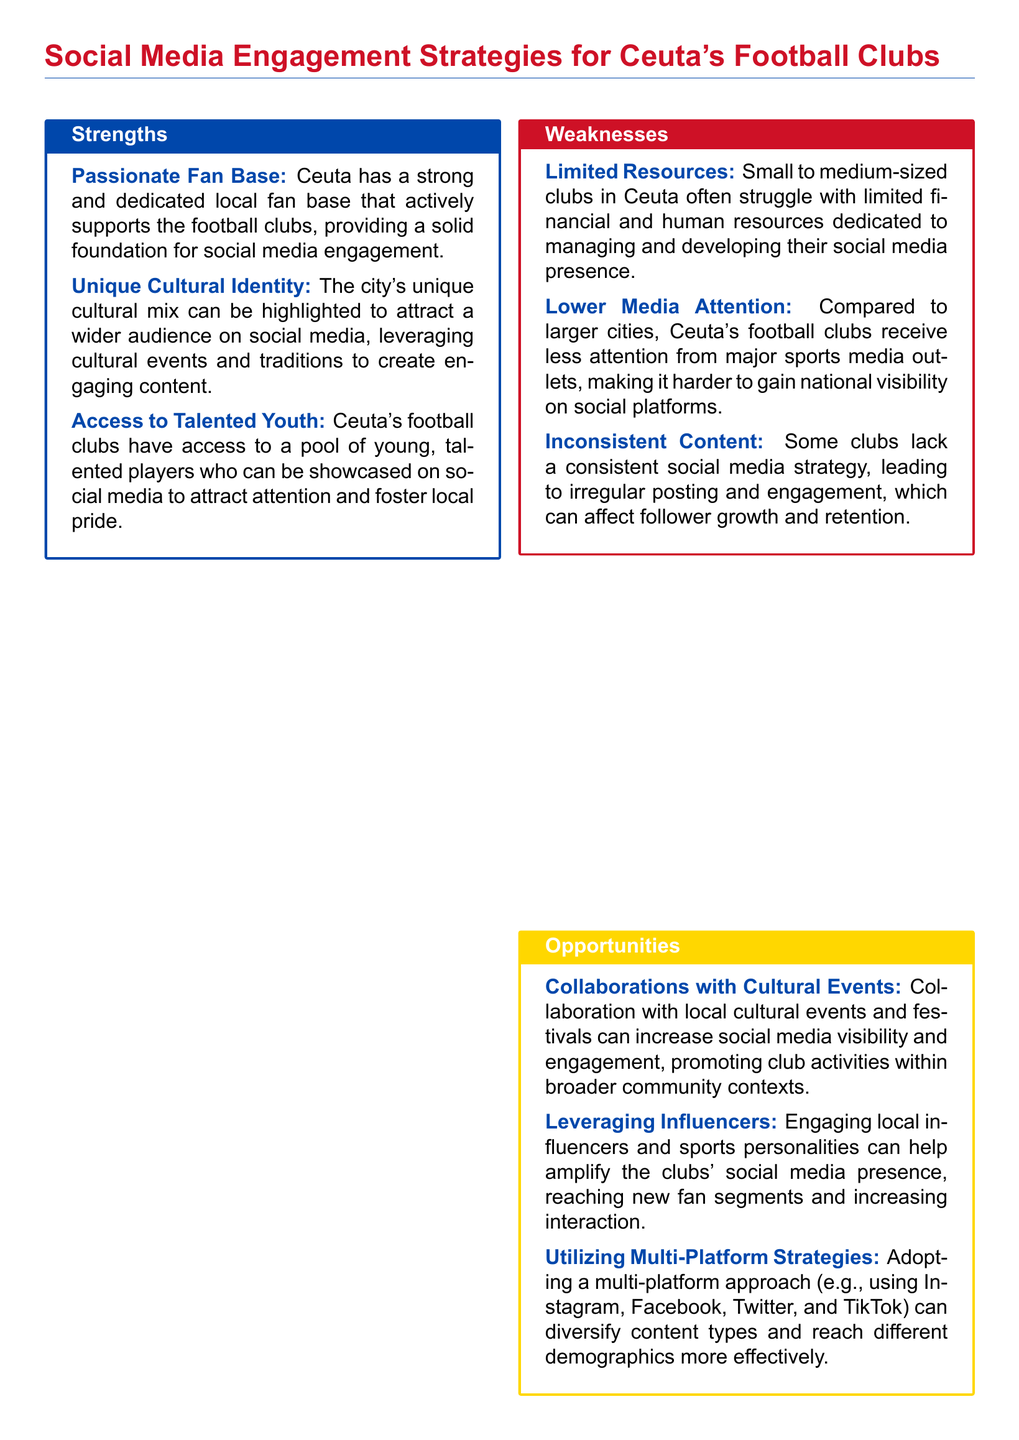What is one strength of Ceuta's football clubs? The strength highlighted in the document is the passionate fan base that supports the football clubs.
Answer: Passionate Fan Base What is a weakness related to media attention? The document mentions that compared to larger cities, Ceuta’s clubs receive less attention from major sports media outlets.
Answer: Lower Media Attention What opportunity involves local cultural events? The document states that collaborating with local cultural events and festivals can increase social media visibility.
Answer: Collaborations with Cultural Events Which threat is linked to competition? The document identifies stiff competition from larger Spanish teams with greater social media followings as a threat.
Answer: Competition from Larger Clubs How many strengths are listed in the document? The document lists three strengths for Ceuta's football clubs.
Answer: 3 What is one way to increase engagement mentioned in the opportunities section? Engaging local influencers and sports personalities can help amplify social media presence.
Answer: Leveraging Influencers What type of content inconsistency is mentioned as a weakness? The document notes some clubs lack a consistent social media strategy, leading to irregular posting and engagement.
Answer: Inconsistent Content What is a potential threat related to social media algorithms? Changes in social media platform algorithms can affect the visibility of posts from Ceuta's clubs.
Answer: Algorithm Changes 